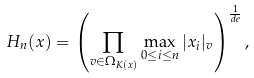Convert formula to latex. <formula><loc_0><loc_0><loc_500><loc_500>H _ { n } ( x ) = \left ( \prod _ { v \in \Omega _ { K ( x ) } } \max _ { 0 \leq i \leq n } | x _ { i } | _ { v } \right ) ^ { \frac { 1 } { d e } } ,</formula> 